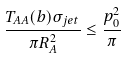<formula> <loc_0><loc_0><loc_500><loc_500>\frac { T _ { A A } ( b ) \sigma _ { j e t } } { \pi R _ { A } ^ { 2 } } \leq \frac { p _ { 0 } ^ { 2 } } { \pi }</formula> 